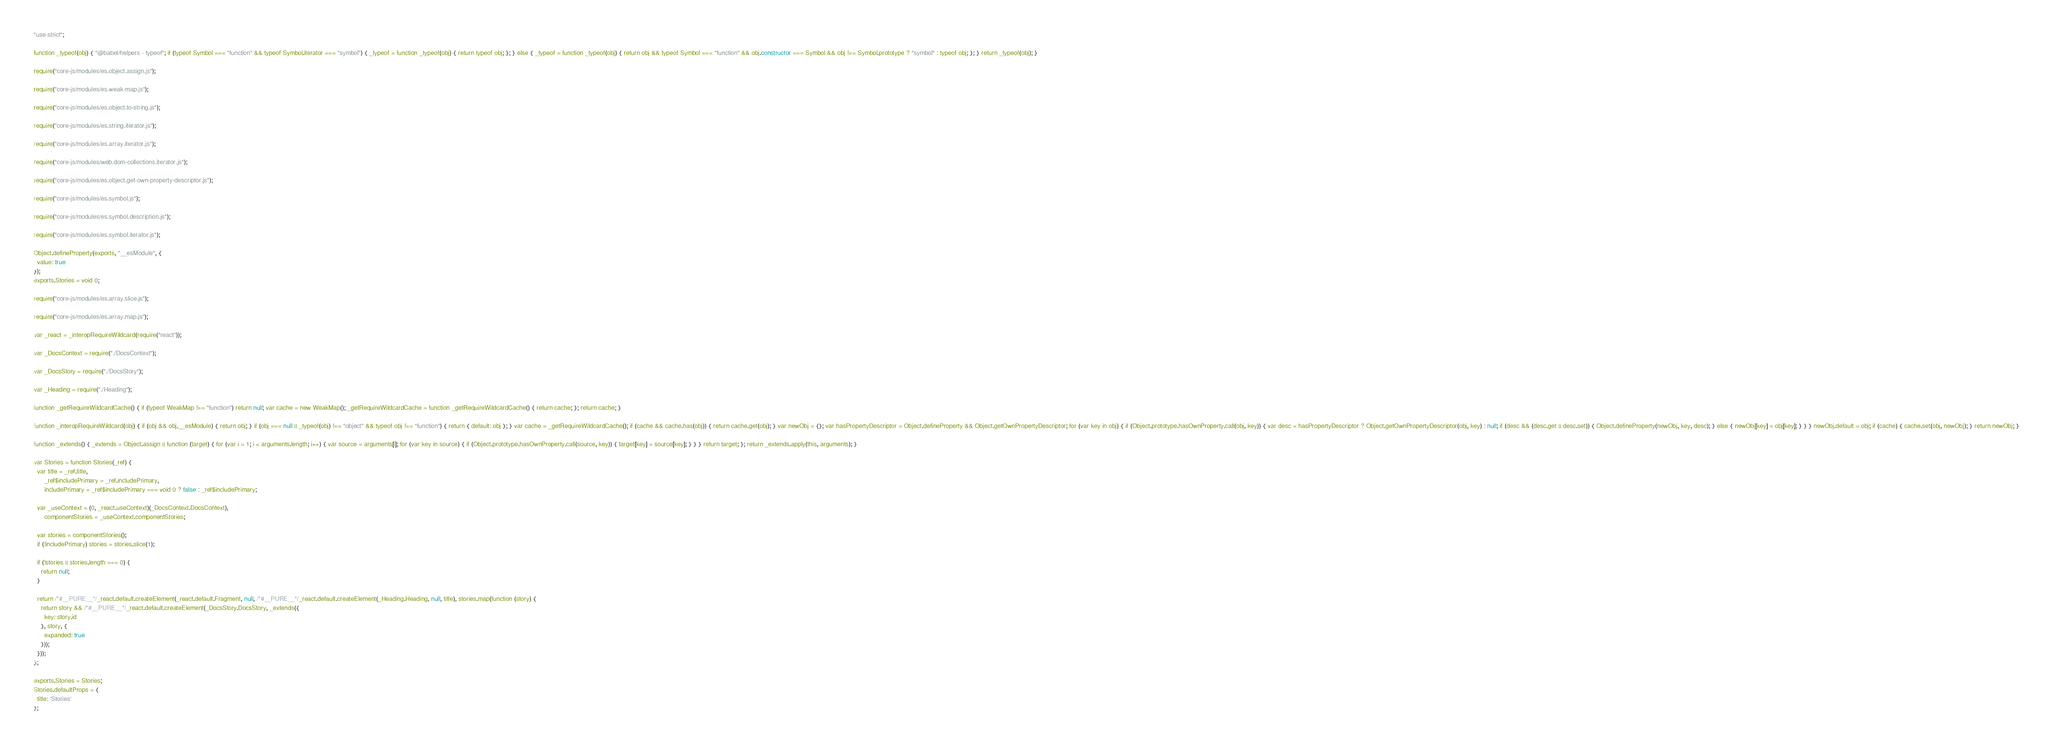Convert code to text. <code><loc_0><loc_0><loc_500><loc_500><_JavaScript_>"use strict";

function _typeof(obj) { "@babel/helpers - typeof"; if (typeof Symbol === "function" && typeof Symbol.iterator === "symbol") { _typeof = function _typeof(obj) { return typeof obj; }; } else { _typeof = function _typeof(obj) { return obj && typeof Symbol === "function" && obj.constructor === Symbol && obj !== Symbol.prototype ? "symbol" : typeof obj; }; } return _typeof(obj); }

require("core-js/modules/es.object.assign.js");

require("core-js/modules/es.weak-map.js");

require("core-js/modules/es.object.to-string.js");

require("core-js/modules/es.string.iterator.js");

require("core-js/modules/es.array.iterator.js");

require("core-js/modules/web.dom-collections.iterator.js");

require("core-js/modules/es.object.get-own-property-descriptor.js");

require("core-js/modules/es.symbol.js");

require("core-js/modules/es.symbol.description.js");

require("core-js/modules/es.symbol.iterator.js");

Object.defineProperty(exports, "__esModule", {
  value: true
});
exports.Stories = void 0;

require("core-js/modules/es.array.slice.js");

require("core-js/modules/es.array.map.js");

var _react = _interopRequireWildcard(require("react"));

var _DocsContext = require("./DocsContext");

var _DocsStory = require("./DocsStory");

var _Heading = require("./Heading");

function _getRequireWildcardCache() { if (typeof WeakMap !== "function") return null; var cache = new WeakMap(); _getRequireWildcardCache = function _getRequireWildcardCache() { return cache; }; return cache; }

function _interopRequireWildcard(obj) { if (obj && obj.__esModule) { return obj; } if (obj === null || _typeof(obj) !== "object" && typeof obj !== "function") { return { default: obj }; } var cache = _getRequireWildcardCache(); if (cache && cache.has(obj)) { return cache.get(obj); } var newObj = {}; var hasPropertyDescriptor = Object.defineProperty && Object.getOwnPropertyDescriptor; for (var key in obj) { if (Object.prototype.hasOwnProperty.call(obj, key)) { var desc = hasPropertyDescriptor ? Object.getOwnPropertyDescriptor(obj, key) : null; if (desc && (desc.get || desc.set)) { Object.defineProperty(newObj, key, desc); } else { newObj[key] = obj[key]; } } } newObj.default = obj; if (cache) { cache.set(obj, newObj); } return newObj; }

function _extends() { _extends = Object.assign || function (target) { for (var i = 1; i < arguments.length; i++) { var source = arguments[i]; for (var key in source) { if (Object.prototype.hasOwnProperty.call(source, key)) { target[key] = source[key]; } } } return target; }; return _extends.apply(this, arguments); }

var Stories = function Stories(_ref) {
  var title = _ref.title,
      _ref$includePrimary = _ref.includePrimary,
      includePrimary = _ref$includePrimary === void 0 ? false : _ref$includePrimary;

  var _useContext = (0, _react.useContext)(_DocsContext.DocsContext),
      componentStories = _useContext.componentStories;

  var stories = componentStories();
  if (!includePrimary) stories = stories.slice(1);

  if (!stories || stories.length === 0) {
    return null;
  }

  return /*#__PURE__*/_react.default.createElement(_react.default.Fragment, null, /*#__PURE__*/_react.default.createElement(_Heading.Heading, null, title), stories.map(function (story) {
    return story && /*#__PURE__*/_react.default.createElement(_DocsStory.DocsStory, _extends({
      key: story.id
    }, story, {
      expanded: true
    }));
  }));
};

exports.Stories = Stories;
Stories.defaultProps = {
  title: 'Stories'
};</code> 